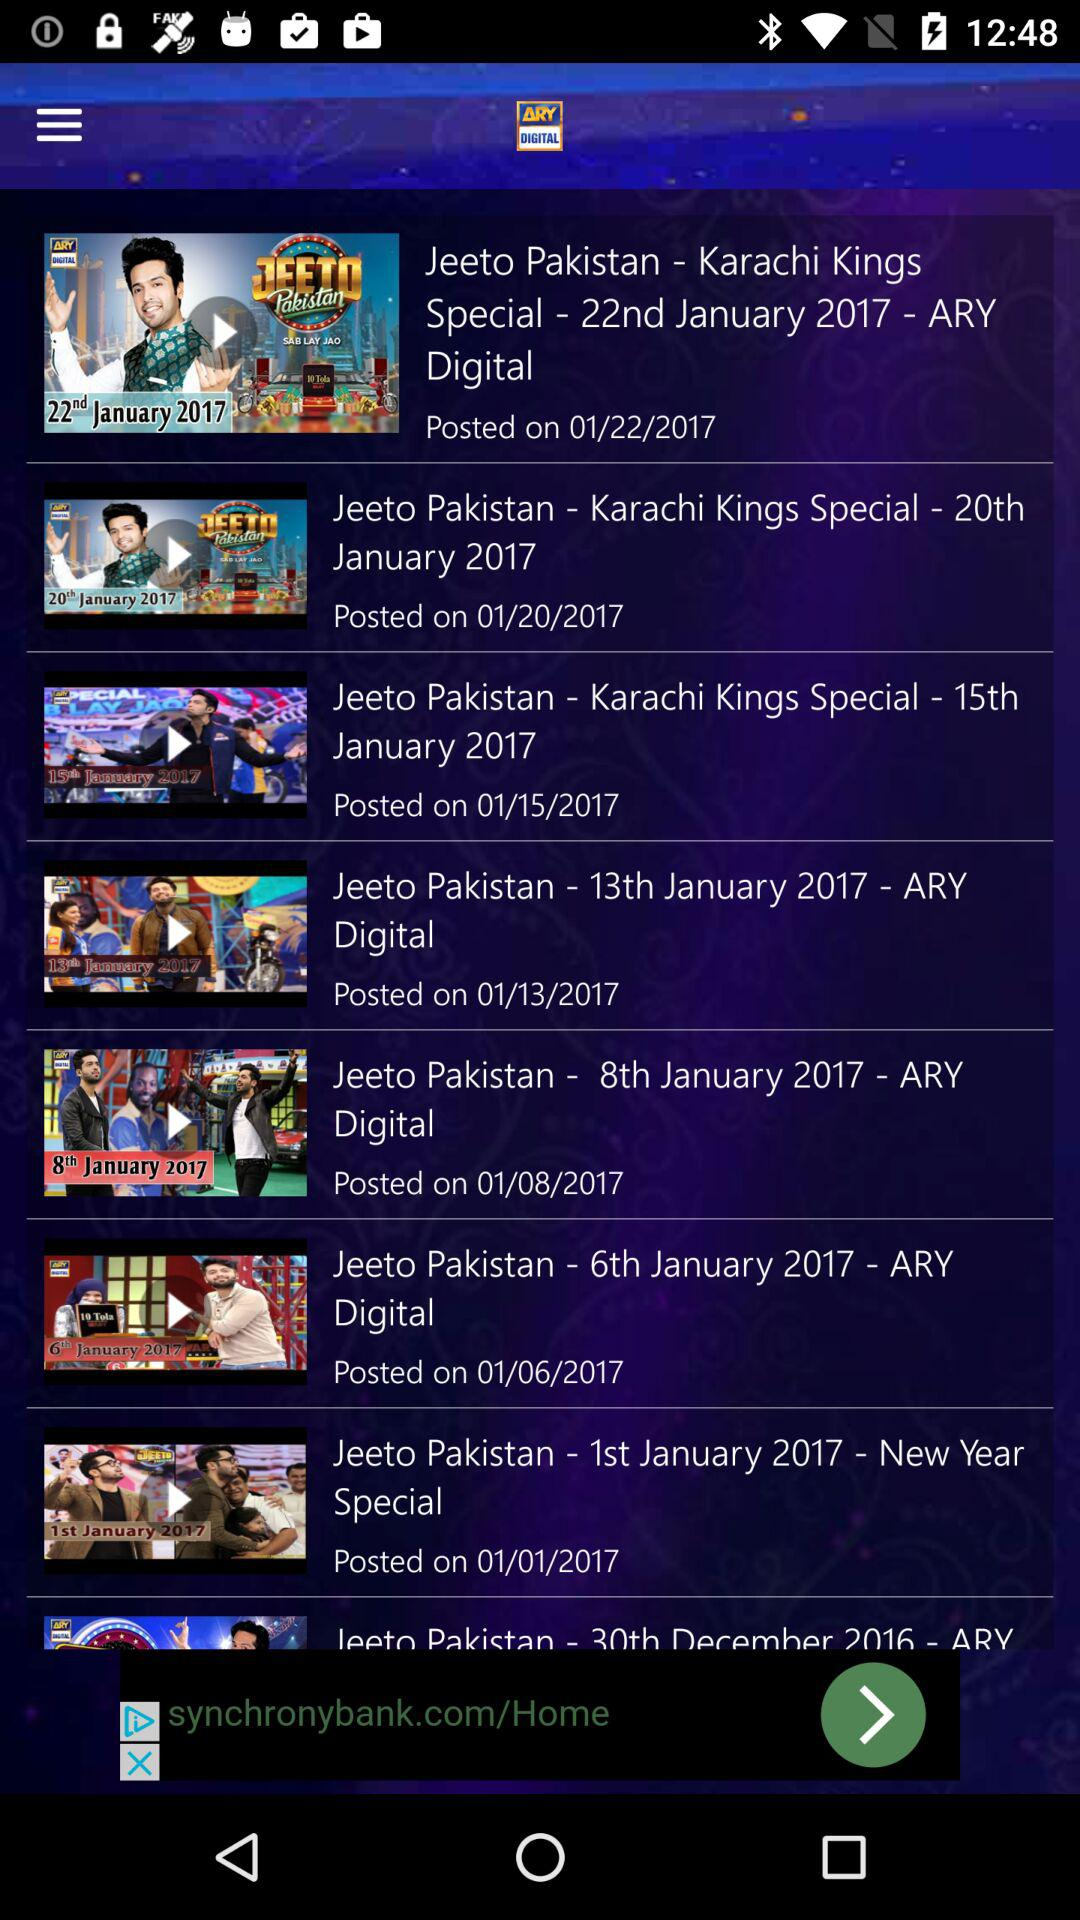The New Year special episode of "Jeeto Pakistan" was aired on what date? It was aired on January 1, 2017. 